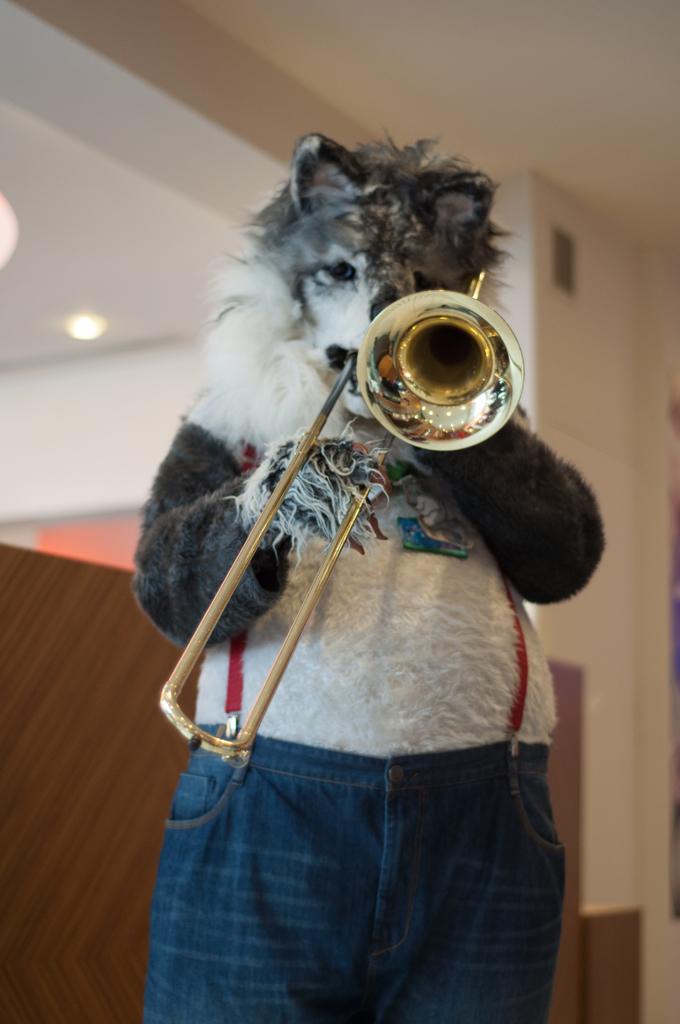In one or two sentences, can you explain what this image depicts? In this image we can see a person is wearing animal costume and holding musical instrument. Behind white color roof and brown wall is present. 